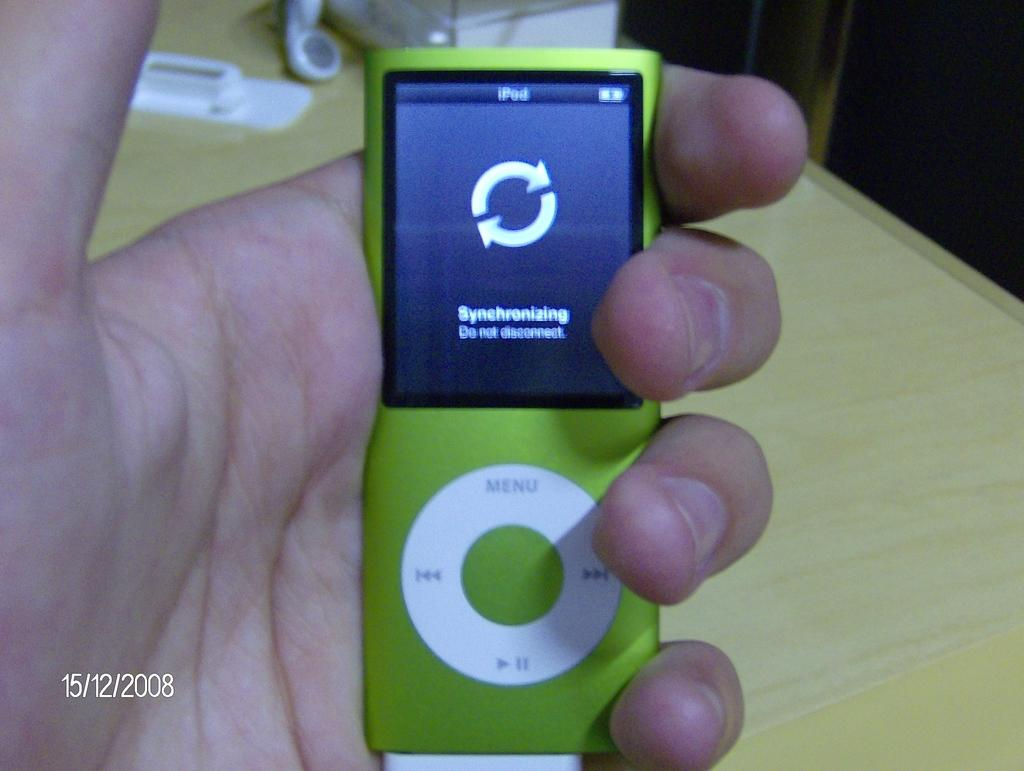What is the person holding in the image? There is a person's hand holding a remote in the image. What can be seen in the background of the image? There is a table in the image. What is on the table in the image? There are objects on the table in the image. What day of the week is depicted in the image? The day of the week is not depicted in the image; it only shows a person's hand holding a remote and a table with objects on it. How much butter is visible on the table in the image? There is no butter present in the image. 